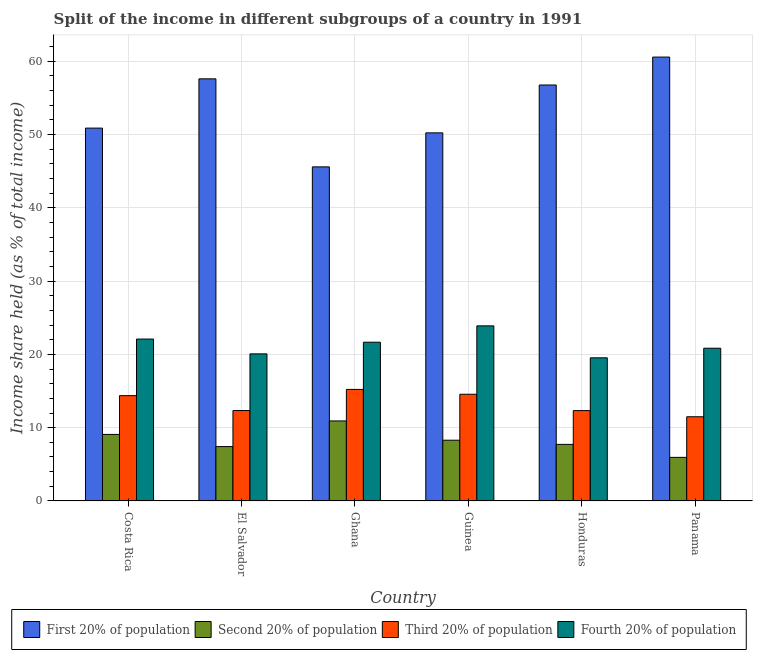How many different coloured bars are there?
Your response must be concise. 4. How many groups of bars are there?
Offer a terse response. 6. Are the number of bars per tick equal to the number of legend labels?
Make the answer very short. Yes. Are the number of bars on each tick of the X-axis equal?
Give a very brief answer. Yes. How many bars are there on the 5th tick from the right?
Provide a short and direct response. 4. What is the share of the income held by second 20% of the population in Ghana?
Your answer should be compact. 10.92. Across all countries, what is the maximum share of the income held by second 20% of the population?
Your answer should be compact. 10.92. Across all countries, what is the minimum share of the income held by third 20% of the population?
Offer a terse response. 11.49. In which country was the share of the income held by third 20% of the population maximum?
Make the answer very short. Ghana. In which country was the share of the income held by first 20% of the population minimum?
Provide a succinct answer. Ghana. What is the total share of the income held by third 20% of the population in the graph?
Your answer should be very brief. 80.31. What is the difference between the share of the income held by fourth 20% of the population in El Salvador and that in Guinea?
Give a very brief answer. -3.82. What is the difference between the share of the income held by second 20% of the population in Panama and the share of the income held by fourth 20% of the population in Guinea?
Your response must be concise. -17.94. What is the average share of the income held by fourth 20% of the population per country?
Ensure brevity in your answer.  21.35. What is the difference between the share of the income held by second 20% of the population and share of the income held by third 20% of the population in Ghana?
Provide a short and direct response. -4.3. In how many countries, is the share of the income held by first 20% of the population greater than 58 %?
Ensure brevity in your answer.  1. What is the ratio of the share of the income held by second 20% of the population in El Salvador to that in Panama?
Your response must be concise. 1.25. Is the difference between the share of the income held by third 20% of the population in Ghana and Panama greater than the difference between the share of the income held by second 20% of the population in Ghana and Panama?
Ensure brevity in your answer.  No. What is the difference between the highest and the second highest share of the income held by first 20% of the population?
Give a very brief answer. 2.97. What is the difference between the highest and the lowest share of the income held by third 20% of the population?
Make the answer very short. 3.73. What does the 4th bar from the left in Guinea represents?
Ensure brevity in your answer.  Fourth 20% of population. What does the 3rd bar from the right in Costa Rica represents?
Offer a very short reply. Second 20% of population. Is it the case that in every country, the sum of the share of the income held by first 20% of the population and share of the income held by second 20% of the population is greater than the share of the income held by third 20% of the population?
Provide a short and direct response. Yes. How many bars are there?
Give a very brief answer. 24. Are all the bars in the graph horizontal?
Make the answer very short. No. How many countries are there in the graph?
Your answer should be very brief. 6. What is the difference between two consecutive major ticks on the Y-axis?
Make the answer very short. 10. Are the values on the major ticks of Y-axis written in scientific E-notation?
Your response must be concise. No. Does the graph contain any zero values?
Your response must be concise. No. How are the legend labels stacked?
Your answer should be very brief. Horizontal. What is the title of the graph?
Provide a short and direct response. Split of the income in different subgroups of a country in 1991. Does "Financial sector" appear as one of the legend labels in the graph?
Provide a succinct answer. No. What is the label or title of the Y-axis?
Ensure brevity in your answer.  Income share held (as % of total income). What is the Income share held (as % of total income) in First 20% of population in Costa Rica?
Provide a succinct answer. 50.87. What is the Income share held (as % of total income) in Second 20% of population in Costa Rica?
Give a very brief answer. 9.08. What is the Income share held (as % of total income) in Third 20% of population in Costa Rica?
Make the answer very short. 14.37. What is the Income share held (as % of total income) in Fourth 20% of population in Costa Rica?
Make the answer very short. 22.09. What is the Income share held (as % of total income) in First 20% of population in El Salvador?
Keep it short and to the point. 57.59. What is the Income share held (as % of total income) in Second 20% of population in El Salvador?
Provide a short and direct response. 7.42. What is the Income share held (as % of total income) in Third 20% of population in El Salvador?
Keep it short and to the point. 12.34. What is the Income share held (as % of total income) in Fourth 20% of population in El Salvador?
Provide a short and direct response. 20.07. What is the Income share held (as % of total income) in First 20% of population in Ghana?
Ensure brevity in your answer.  45.58. What is the Income share held (as % of total income) of Second 20% of population in Ghana?
Offer a terse response. 10.92. What is the Income share held (as % of total income) of Third 20% of population in Ghana?
Provide a succinct answer. 15.22. What is the Income share held (as % of total income) in Fourth 20% of population in Ghana?
Make the answer very short. 21.66. What is the Income share held (as % of total income) of First 20% of population in Guinea?
Your response must be concise. 50.22. What is the Income share held (as % of total income) of Second 20% of population in Guinea?
Provide a succinct answer. 8.29. What is the Income share held (as % of total income) of Third 20% of population in Guinea?
Make the answer very short. 14.56. What is the Income share held (as % of total income) of Fourth 20% of population in Guinea?
Keep it short and to the point. 23.89. What is the Income share held (as % of total income) in First 20% of population in Honduras?
Ensure brevity in your answer.  56.75. What is the Income share held (as % of total income) in Second 20% of population in Honduras?
Your answer should be compact. 7.72. What is the Income share held (as % of total income) of Third 20% of population in Honduras?
Make the answer very short. 12.33. What is the Income share held (as % of total income) in Fourth 20% of population in Honduras?
Provide a short and direct response. 19.53. What is the Income share held (as % of total income) in First 20% of population in Panama?
Give a very brief answer. 60.56. What is the Income share held (as % of total income) of Second 20% of population in Panama?
Your answer should be compact. 5.95. What is the Income share held (as % of total income) of Third 20% of population in Panama?
Provide a short and direct response. 11.49. What is the Income share held (as % of total income) in Fourth 20% of population in Panama?
Provide a succinct answer. 20.84. Across all countries, what is the maximum Income share held (as % of total income) in First 20% of population?
Your answer should be compact. 60.56. Across all countries, what is the maximum Income share held (as % of total income) in Second 20% of population?
Keep it short and to the point. 10.92. Across all countries, what is the maximum Income share held (as % of total income) of Third 20% of population?
Your answer should be compact. 15.22. Across all countries, what is the maximum Income share held (as % of total income) of Fourth 20% of population?
Your answer should be compact. 23.89. Across all countries, what is the minimum Income share held (as % of total income) in First 20% of population?
Make the answer very short. 45.58. Across all countries, what is the minimum Income share held (as % of total income) of Second 20% of population?
Offer a very short reply. 5.95. Across all countries, what is the minimum Income share held (as % of total income) in Third 20% of population?
Your answer should be compact. 11.49. Across all countries, what is the minimum Income share held (as % of total income) in Fourth 20% of population?
Your response must be concise. 19.53. What is the total Income share held (as % of total income) of First 20% of population in the graph?
Your answer should be compact. 321.57. What is the total Income share held (as % of total income) of Second 20% of population in the graph?
Make the answer very short. 49.38. What is the total Income share held (as % of total income) of Third 20% of population in the graph?
Your answer should be compact. 80.31. What is the total Income share held (as % of total income) of Fourth 20% of population in the graph?
Offer a very short reply. 128.08. What is the difference between the Income share held (as % of total income) of First 20% of population in Costa Rica and that in El Salvador?
Give a very brief answer. -6.72. What is the difference between the Income share held (as % of total income) of Second 20% of population in Costa Rica and that in El Salvador?
Your answer should be very brief. 1.66. What is the difference between the Income share held (as % of total income) of Third 20% of population in Costa Rica and that in El Salvador?
Offer a very short reply. 2.03. What is the difference between the Income share held (as % of total income) in Fourth 20% of population in Costa Rica and that in El Salvador?
Your answer should be very brief. 2.02. What is the difference between the Income share held (as % of total income) of First 20% of population in Costa Rica and that in Ghana?
Provide a succinct answer. 5.29. What is the difference between the Income share held (as % of total income) in Second 20% of population in Costa Rica and that in Ghana?
Provide a succinct answer. -1.84. What is the difference between the Income share held (as % of total income) in Third 20% of population in Costa Rica and that in Ghana?
Give a very brief answer. -0.85. What is the difference between the Income share held (as % of total income) in Fourth 20% of population in Costa Rica and that in Ghana?
Offer a terse response. 0.43. What is the difference between the Income share held (as % of total income) in First 20% of population in Costa Rica and that in Guinea?
Offer a terse response. 0.65. What is the difference between the Income share held (as % of total income) of Second 20% of population in Costa Rica and that in Guinea?
Provide a short and direct response. 0.79. What is the difference between the Income share held (as % of total income) of Third 20% of population in Costa Rica and that in Guinea?
Your answer should be compact. -0.19. What is the difference between the Income share held (as % of total income) of First 20% of population in Costa Rica and that in Honduras?
Provide a succinct answer. -5.88. What is the difference between the Income share held (as % of total income) of Second 20% of population in Costa Rica and that in Honduras?
Give a very brief answer. 1.36. What is the difference between the Income share held (as % of total income) in Third 20% of population in Costa Rica and that in Honduras?
Make the answer very short. 2.04. What is the difference between the Income share held (as % of total income) of Fourth 20% of population in Costa Rica and that in Honduras?
Your answer should be compact. 2.56. What is the difference between the Income share held (as % of total income) of First 20% of population in Costa Rica and that in Panama?
Your answer should be very brief. -9.69. What is the difference between the Income share held (as % of total income) of Second 20% of population in Costa Rica and that in Panama?
Provide a succinct answer. 3.13. What is the difference between the Income share held (as % of total income) in Third 20% of population in Costa Rica and that in Panama?
Provide a short and direct response. 2.88. What is the difference between the Income share held (as % of total income) of First 20% of population in El Salvador and that in Ghana?
Offer a very short reply. 12.01. What is the difference between the Income share held (as % of total income) in Second 20% of population in El Salvador and that in Ghana?
Keep it short and to the point. -3.5. What is the difference between the Income share held (as % of total income) in Third 20% of population in El Salvador and that in Ghana?
Provide a short and direct response. -2.88. What is the difference between the Income share held (as % of total income) in Fourth 20% of population in El Salvador and that in Ghana?
Your response must be concise. -1.59. What is the difference between the Income share held (as % of total income) of First 20% of population in El Salvador and that in Guinea?
Offer a very short reply. 7.37. What is the difference between the Income share held (as % of total income) in Second 20% of population in El Salvador and that in Guinea?
Your response must be concise. -0.87. What is the difference between the Income share held (as % of total income) in Third 20% of population in El Salvador and that in Guinea?
Offer a very short reply. -2.22. What is the difference between the Income share held (as % of total income) in Fourth 20% of population in El Salvador and that in Guinea?
Your answer should be compact. -3.82. What is the difference between the Income share held (as % of total income) in First 20% of population in El Salvador and that in Honduras?
Your answer should be very brief. 0.84. What is the difference between the Income share held (as % of total income) in Second 20% of population in El Salvador and that in Honduras?
Ensure brevity in your answer.  -0.3. What is the difference between the Income share held (as % of total income) of Third 20% of population in El Salvador and that in Honduras?
Give a very brief answer. 0.01. What is the difference between the Income share held (as % of total income) in Fourth 20% of population in El Salvador and that in Honduras?
Offer a terse response. 0.54. What is the difference between the Income share held (as % of total income) in First 20% of population in El Salvador and that in Panama?
Keep it short and to the point. -2.97. What is the difference between the Income share held (as % of total income) of Second 20% of population in El Salvador and that in Panama?
Keep it short and to the point. 1.47. What is the difference between the Income share held (as % of total income) in Third 20% of population in El Salvador and that in Panama?
Ensure brevity in your answer.  0.85. What is the difference between the Income share held (as % of total income) of Fourth 20% of population in El Salvador and that in Panama?
Provide a short and direct response. -0.77. What is the difference between the Income share held (as % of total income) in First 20% of population in Ghana and that in Guinea?
Offer a terse response. -4.64. What is the difference between the Income share held (as % of total income) in Second 20% of population in Ghana and that in Guinea?
Your answer should be very brief. 2.63. What is the difference between the Income share held (as % of total income) of Third 20% of population in Ghana and that in Guinea?
Keep it short and to the point. 0.66. What is the difference between the Income share held (as % of total income) of Fourth 20% of population in Ghana and that in Guinea?
Offer a very short reply. -2.23. What is the difference between the Income share held (as % of total income) of First 20% of population in Ghana and that in Honduras?
Give a very brief answer. -11.17. What is the difference between the Income share held (as % of total income) of Second 20% of population in Ghana and that in Honduras?
Offer a very short reply. 3.2. What is the difference between the Income share held (as % of total income) in Third 20% of population in Ghana and that in Honduras?
Ensure brevity in your answer.  2.89. What is the difference between the Income share held (as % of total income) of Fourth 20% of population in Ghana and that in Honduras?
Make the answer very short. 2.13. What is the difference between the Income share held (as % of total income) in First 20% of population in Ghana and that in Panama?
Provide a short and direct response. -14.98. What is the difference between the Income share held (as % of total income) of Second 20% of population in Ghana and that in Panama?
Your response must be concise. 4.97. What is the difference between the Income share held (as % of total income) in Third 20% of population in Ghana and that in Panama?
Keep it short and to the point. 3.73. What is the difference between the Income share held (as % of total income) of Fourth 20% of population in Ghana and that in Panama?
Offer a terse response. 0.82. What is the difference between the Income share held (as % of total income) of First 20% of population in Guinea and that in Honduras?
Keep it short and to the point. -6.53. What is the difference between the Income share held (as % of total income) in Second 20% of population in Guinea and that in Honduras?
Offer a terse response. 0.57. What is the difference between the Income share held (as % of total income) of Third 20% of population in Guinea and that in Honduras?
Your response must be concise. 2.23. What is the difference between the Income share held (as % of total income) of Fourth 20% of population in Guinea and that in Honduras?
Make the answer very short. 4.36. What is the difference between the Income share held (as % of total income) in First 20% of population in Guinea and that in Panama?
Your answer should be compact. -10.34. What is the difference between the Income share held (as % of total income) of Second 20% of population in Guinea and that in Panama?
Ensure brevity in your answer.  2.34. What is the difference between the Income share held (as % of total income) of Third 20% of population in Guinea and that in Panama?
Offer a very short reply. 3.07. What is the difference between the Income share held (as % of total income) in Fourth 20% of population in Guinea and that in Panama?
Make the answer very short. 3.05. What is the difference between the Income share held (as % of total income) in First 20% of population in Honduras and that in Panama?
Make the answer very short. -3.81. What is the difference between the Income share held (as % of total income) in Second 20% of population in Honduras and that in Panama?
Keep it short and to the point. 1.77. What is the difference between the Income share held (as % of total income) of Third 20% of population in Honduras and that in Panama?
Your answer should be compact. 0.84. What is the difference between the Income share held (as % of total income) in Fourth 20% of population in Honduras and that in Panama?
Provide a succinct answer. -1.31. What is the difference between the Income share held (as % of total income) in First 20% of population in Costa Rica and the Income share held (as % of total income) in Second 20% of population in El Salvador?
Keep it short and to the point. 43.45. What is the difference between the Income share held (as % of total income) in First 20% of population in Costa Rica and the Income share held (as % of total income) in Third 20% of population in El Salvador?
Your response must be concise. 38.53. What is the difference between the Income share held (as % of total income) in First 20% of population in Costa Rica and the Income share held (as % of total income) in Fourth 20% of population in El Salvador?
Offer a terse response. 30.8. What is the difference between the Income share held (as % of total income) of Second 20% of population in Costa Rica and the Income share held (as % of total income) of Third 20% of population in El Salvador?
Provide a succinct answer. -3.26. What is the difference between the Income share held (as % of total income) of Second 20% of population in Costa Rica and the Income share held (as % of total income) of Fourth 20% of population in El Salvador?
Give a very brief answer. -10.99. What is the difference between the Income share held (as % of total income) of Third 20% of population in Costa Rica and the Income share held (as % of total income) of Fourth 20% of population in El Salvador?
Your answer should be compact. -5.7. What is the difference between the Income share held (as % of total income) of First 20% of population in Costa Rica and the Income share held (as % of total income) of Second 20% of population in Ghana?
Provide a succinct answer. 39.95. What is the difference between the Income share held (as % of total income) in First 20% of population in Costa Rica and the Income share held (as % of total income) in Third 20% of population in Ghana?
Your response must be concise. 35.65. What is the difference between the Income share held (as % of total income) of First 20% of population in Costa Rica and the Income share held (as % of total income) of Fourth 20% of population in Ghana?
Your answer should be very brief. 29.21. What is the difference between the Income share held (as % of total income) of Second 20% of population in Costa Rica and the Income share held (as % of total income) of Third 20% of population in Ghana?
Offer a terse response. -6.14. What is the difference between the Income share held (as % of total income) of Second 20% of population in Costa Rica and the Income share held (as % of total income) of Fourth 20% of population in Ghana?
Offer a terse response. -12.58. What is the difference between the Income share held (as % of total income) in Third 20% of population in Costa Rica and the Income share held (as % of total income) in Fourth 20% of population in Ghana?
Ensure brevity in your answer.  -7.29. What is the difference between the Income share held (as % of total income) in First 20% of population in Costa Rica and the Income share held (as % of total income) in Second 20% of population in Guinea?
Your response must be concise. 42.58. What is the difference between the Income share held (as % of total income) of First 20% of population in Costa Rica and the Income share held (as % of total income) of Third 20% of population in Guinea?
Your answer should be compact. 36.31. What is the difference between the Income share held (as % of total income) of First 20% of population in Costa Rica and the Income share held (as % of total income) of Fourth 20% of population in Guinea?
Your answer should be very brief. 26.98. What is the difference between the Income share held (as % of total income) in Second 20% of population in Costa Rica and the Income share held (as % of total income) in Third 20% of population in Guinea?
Offer a terse response. -5.48. What is the difference between the Income share held (as % of total income) of Second 20% of population in Costa Rica and the Income share held (as % of total income) of Fourth 20% of population in Guinea?
Give a very brief answer. -14.81. What is the difference between the Income share held (as % of total income) of Third 20% of population in Costa Rica and the Income share held (as % of total income) of Fourth 20% of population in Guinea?
Your response must be concise. -9.52. What is the difference between the Income share held (as % of total income) in First 20% of population in Costa Rica and the Income share held (as % of total income) in Second 20% of population in Honduras?
Make the answer very short. 43.15. What is the difference between the Income share held (as % of total income) of First 20% of population in Costa Rica and the Income share held (as % of total income) of Third 20% of population in Honduras?
Your answer should be very brief. 38.54. What is the difference between the Income share held (as % of total income) in First 20% of population in Costa Rica and the Income share held (as % of total income) in Fourth 20% of population in Honduras?
Keep it short and to the point. 31.34. What is the difference between the Income share held (as % of total income) of Second 20% of population in Costa Rica and the Income share held (as % of total income) of Third 20% of population in Honduras?
Provide a short and direct response. -3.25. What is the difference between the Income share held (as % of total income) in Second 20% of population in Costa Rica and the Income share held (as % of total income) in Fourth 20% of population in Honduras?
Provide a succinct answer. -10.45. What is the difference between the Income share held (as % of total income) in Third 20% of population in Costa Rica and the Income share held (as % of total income) in Fourth 20% of population in Honduras?
Make the answer very short. -5.16. What is the difference between the Income share held (as % of total income) in First 20% of population in Costa Rica and the Income share held (as % of total income) in Second 20% of population in Panama?
Your answer should be very brief. 44.92. What is the difference between the Income share held (as % of total income) in First 20% of population in Costa Rica and the Income share held (as % of total income) in Third 20% of population in Panama?
Offer a terse response. 39.38. What is the difference between the Income share held (as % of total income) of First 20% of population in Costa Rica and the Income share held (as % of total income) of Fourth 20% of population in Panama?
Your answer should be compact. 30.03. What is the difference between the Income share held (as % of total income) of Second 20% of population in Costa Rica and the Income share held (as % of total income) of Third 20% of population in Panama?
Offer a very short reply. -2.41. What is the difference between the Income share held (as % of total income) of Second 20% of population in Costa Rica and the Income share held (as % of total income) of Fourth 20% of population in Panama?
Ensure brevity in your answer.  -11.76. What is the difference between the Income share held (as % of total income) of Third 20% of population in Costa Rica and the Income share held (as % of total income) of Fourth 20% of population in Panama?
Give a very brief answer. -6.47. What is the difference between the Income share held (as % of total income) of First 20% of population in El Salvador and the Income share held (as % of total income) of Second 20% of population in Ghana?
Keep it short and to the point. 46.67. What is the difference between the Income share held (as % of total income) in First 20% of population in El Salvador and the Income share held (as % of total income) in Third 20% of population in Ghana?
Make the answer very short. 42.37. What is the difference between the Income share held (as % of total income) of First 20% of population in El Salvador and the Income share held (as % of total income) of Fourth 20% of population in Ghana?
Offer a very short reply. 35.93. What is the difference between the Income share held (as % of total income) of Second 20% of population in El Salvador and the Income share held (as % of total income) of Fourth 20% of population in Ghana?
Offer a terse response. -14.24. What is the difference between the Income share held (as % of total income) of Third 20% of population in El Salvador and the Income share held (as % of total income) of Fourth 20% of population in Ghana?
Give a very brief answer. -9.32. What is the difference between the Income share held (as % of total income) in First 20% of population in El Salvador and the Income share held (as % of total income) in Second 20% of population in Guinea?
Ensure brevity in your answer.  49.3. What is the difference between the Income share held (as % of total income) in First 20% of population in El Salvador and the Income share held (as % of total income) in Third 20% of population in Guinea?
Provide a succinct answer. 43.03. What is the difference between the Income share held (as % of total income) of First 20% of population in El Salvador and the Income share held (as % of total income) of Fourth 20% of population in Guinea?
Keep it short and to the point. 33.7. What is the difference between the Income share held (as % of total income) of Second 20% of population in El Salvador and the Income share held (as % of total income) of Third 20% of population in Guinea?
Offer a very short reply. -7.14. What is the difference between the Income share held (as % of total income) in Second 20% of population in El Salvador and the Income share held (as % of total income) in Fourth 20% of population in Guinea?
Provide a succinct answer. -16.47. What is the difference between the Income share held (as % of total income) in Third 20% of population in El Salvador and the Income share held (as % of total income) in Fourth 20% of population in Guinea?
Provide a succinct answer. -11.55. What is the difference between the Income share held (as % of total income) in First 20% of population in El Salvador and the Income share held (as % of total income) in Second 20% of population in Honduras?
Your answer should be compact. 49.87. What is the difference between the Income share held (as % of total income) in First 20% of population in El Salvador and the Income share held (as % of total income) in Third 20% of population in Honduras?
Your answer should be very brief. 45.26. What is the difference between the Income share held (as % of total income) of First 20% of population in El Salvador and the Income share held (as % of total income) of Fourth 20% of population in Honduras?
Provide a succinct answer. 38.06. What is the difference between the Income share held (as % of total income) of Second 20% of population in El Salvador and the Income share held (as % of total income) of Third 20% of population in Honduras?
Offer a very short reply. -4.91. What is the difference between the Income share held (as % of total income) in Second 20% of population in El Salvador and the Income share held (as % of total income) in Fourth 20% of population in Honduras?
Offer a very short reply. -12.11. What is the difference between the Income share held (as % of total income) of Third 20% of population in El Salvador and the Income share held (as % of total income) of Fourth 20% of population in Honduras?
Ensure brevity in your answer.  -7.19. What is the difference between the Income share held (as % of total income) of First 20% of population in El Salvador and the Income share held (as % of total income) of Second 20% of population in Panama?
Your answer should be very brief. 51.64. What is the difference between the Income share held (as % of total income) of First 20% of population in El Salvador and the Income share held (as % of total income) of Third 20% of population in Panama?
Offer a very short reply. 46.1. What is the difference between the Income share held (as % of total income) of First 20% of population in El Salvador and the Income share held (as % of total income) of Fourth 20% of population in Panama?
Give a very brief answer. 36.75. What is the difference between the Income share held (as % of total income) in Second 20% of population in El Salvador and the Income share held (as % of total income) in Third 20% of population in Panama?
Your answer should be very brief. -4.07. What is the difference between the Income share held (as % of total income) in Second 20% of population in El Salvador and the Income share held (as % of total income) in Fourth 20% of population in Panama?
Your response must be concise. -13.42. What is the difference between the Income share held (as % of total income) in First 20% of population in Ghana and the Income share held (as % of total income) in Second 20% of population in Guinea?
Your answer should be compact. 37.29. What is the difference between the Income share held (as % of total income) in First 20% of population in Ghana and the Income share held (as % of total income) in Third 20% of population in Guinea?
Provide a succinct answer. 31.02. What is the difference between the Income share held (as % of total income) of First 20% of population in Ghana and the Income share held (as % of total income) of Fourth 20% of population in Guinea?
Ensure brevity in your answer.  21.69. What is the difference between the Income share held (as % of total income) of Second 20% of population in Ghana and the Income share held (as % of total income) of Third 20% of population in Guinea?
Offer a terse response. -3.64. What is the difference between the Income share held (as % of total income) in Second 20% of population in Ghana and the Income share held (as % of total income) in Fourth 20% of population in Guinea?
Provide a succinct answer. -12.97. What is the difference between the Income share held (as % of total income) of Third 20% of population in Ghana and the Income share held (as % of total income) of Fourth 20% of population in Guinea?
Offer a very short reply. -8.67. What is the difference between the Income share held (as % of total income) of First 20% of population in Ghana and the Income share held (as % of total income) of Second 20% of population in Honduras?
Offer a terse response. 37.86. What is the difference between the Income share held (as % of total income) in First 20% of population in Ghana and the Income share held (as % of total income) in Third 20% of population in Honduras?
Make the answer very short. 33.25. What is the difference between the Income share held (as % of total income) of First 20% of population in Ghana and the Income share held (as % of total income) of Fourth 20% of population in Honduras?
Offer a terse response. 26.05. What is the difference between the Income share held (as % of total income) in Second 20% of population in Ghana and the Income share held (as % of total income) in Third 20% of population in Honduras?
Offer a terse response. -1.41. What is the difference between the Income share held (as % of total income) in Second 20% of population in Ghana and the Income share held (as % of total income) in Fourth 20% of population in Honduras?
Provide a succinct answer. -8.61. What is the difference between the Income share held (as % of total income) of Third 20% of population in Ghana and the Income share held (as % of total income) of Fourth 20% of population in Honduras?
Provide a succinct answer. -4.31. What is the difference between the Income share held (as % of total income) in First 20% of population in Ghana and the Income share held (as % of total income) in Second 20% of population in Panama?
Give a very brief answer. 39.63. What is the difference between the Income share held (as % of total income) in First 20% of population in Ghana and the Income share held (as % of total income) in Third 20% of population in Panama?
Make the answer very short. 34.09. What is the difference between the Income share held (as % of total income) of First 20% of population in Ghana and the Income share held (as % of total income) of Fourth 20% of population in Panama?
Provide a short and direct response. 24.74. What is the difference between the Income share held (as % of total income) in Second 20% of population in Ghana and the Income share held (as % of total income) in Third 20% of population in Panama?
Offer a terse response. -0.57. What is the difference between the Income share held (as % of total income) of Second 20% of population in Ghana and the Income share held (as % of total income) of Fourth 20% of population in Panama?
Offer a very short reply. -9.92. What is the difference between the Income share held (as % of total income) of Third 20% of population in Ghana and the Income share held (as % of total income) of Fourth 20% of population in Panama?
Make the answer very short. -5.62. What is the difference between the Income share held (as % of total income) in First 20% of population in Guinea and the Income share held (as % of total income) in Second 20% of population in Honduras?
Provide a succinct answer. 42.5. What is the difference between the Income share held (as % of total income) of First 20% of population in Guinea and the Income share held (as % of total income) of Third 20% of population in Honduras?
Your answer should be very brief. 37.89. What is the difference between the Income share held (as % of total income) of First 20% of population in Guinea and the Income share held (as % of total income) of Fourth 20% of population in Honduras?
Keep it short and to the point. 30.69. What is the difference between the Income share held (as % of total income) in Second 20% of population in Guinea and the Income share held (as % of total income) in Third 20% of population in Honduras?
Your answer should be compact. -4.04. What is the difference between the Income share held (as % of total income) of Second 20% of population in Guinea and the Income share held (as % of total income) of Fourth 20% of population in Honduras?
Provide a succinct answer. -11.24. What is the difference between the Income share held (as % of total income) in Third 20% of population in Guinea and the Income share held (as % of total income) in Fourth 20% of population in Honduras?
Your answer should be compact. -4.97. What is the difference between the Income share held (as % of total income) of First 20% of population in Guinea and the Income share held (as % of total income) of Second 20% of population in Panama?
Offer a terse response. 44.27. What is the difference between the Income share held (as % of total income) of First 20% of population in Guinea and the Income share held (as % of total income) of Third 20% of population in Panama?
Provide a short and direct response. 38.73. What is the difference between the Income share held (as % of total income) of First 20% of population in Guinea and the Income share held (as % of total income) of Fourth 20% of population in Panama?
Offer a terse response. 29.38. What is the difference between the Income share held (as % of total income) in Second 20% of population in Guinea and the Income share held (as % of total income) in Fourth 20% of population in Panama?
Keep it short and to the point. -12.55. What is the difference between the Income share held (as % of total income) of Third 20% of population in Guinea and the Income share held (as % of total income) of Fourth 20% of population in Panama?
Your answer should be compact. -6.28. What is the difference between the Income share held (as % of total income) in First 20% of population in Honduras and the Income share held (as % of total income) in Second 20% of population in Panama?
Offer a very short reply. 50.8. What is the difference between the Income share held (as % of total income) of First 20% of population in Honduras and the Income share held (as % of total income) of Third 20% of population in Panama?
Offer a terse response. 45.26. What is the difference between the Income share held (as % of total income) of First 20% of population in Honduras and the Income share held (as % of total income) of Fourth 20% of population in Panama?
Provide a succinct answer. 35.91. What is the difference between the Income share held (as % of total income) of Second 20% of population in Honduras and the Income share held (as % of total income) of Third 20% of population in Panama?
Keep it short and to the point. -3.77. What is the difference between the Income share held (as % of total income) of Second 20% of population in Honduras and the Income share held (as % of total income) of Fourth 20% of population in Panama?
Your response must be concise. -13.12. What is the difference between the Income share held (as % of total income) in Third 20% of population in Honduras and the Income share held (as % of total income) in Fourth 20% of population in Panama?
Your answer should be very brief. -8.51. What is the average Income share held (as % of total income) in First 20% of population per country?
Provide a short and direct response. 53.59. What is the average Income share held (as % of total income) in Second 20% of population per country?
Offer a terse response. 8.23. What is the average Income share held (as % of total income) of Third 20% of population per country?
Keep it short and to the point. 13.38. What is the average Income share held (as % of total income) in Fourth 20% of population per country?
Provide a short and direct response. 21.35. What is the difference between the Income share held (as % of total income) in First 20% of population and Income share held (as % of total income) in Second 20% of population in Costa Rica?
Make the answer very short. 41.79. What is the difference between the Income share held (as % of total income) in First 20% of population and Income share held (as % of total income) in Third 20% of population in Costa Rica?
Keep it short and to the point. 36.5. What is the difference between the Income share held (as % of total income) of First 20% of population and Income share held (as % of total income) of Fourth 20% of population in Costa Rica?
Ensure brevity in your answer.  28.78. What is the difference between the Income share held (as % of total income) of Second 20% of population and Income share held (as % of total income) of Third 20% of population in Costa Rica?
Ensure brevity in your answer.  -5.29. What is the difference between the Income share held (as % of total income) of Second 20% of population and Income share held (as % of total income) of Fourth 20% of population in Costa Rica?
Provide a succinct answer. -13.01. What is the difference between the Income share held (as % of total income) in Third 20% of population and Income share held (as % of total income) in Fourth 20% of population in Costa Rica?
Offer a terse response. -7.72. What is the difference between the Income share held (as % of total income) in First 20% of population and Income share held (as % of total income) in Second 20% of population in El Salvador?
Your answer should be compact. 50.17. What is the difference between the Income share held (as % of total income) of First 20% of population and Income share held (as % of total income) of Third 20% of population in El Salvador?
Make the answer very short. 45.25. What is the difference between the Income share held (as % of total income) in First 20% of population and Income share held (as % of total income) in Fourth 20% of population in El Salvador?
Offer a very short reply. 37.52. What is the difference between the Income share held (as % of total income) of Second 20% of population and Income share held (as % of total income) of Third 20% of population in El Salvador?
Make the answer very short. -4.92. What is the difference between the Income share held (as % of total income) of Second 20% of population and Income share held (as % of total income) of Fourth 20% of population in El Salvador?
Your answer should be compact. -12.65. What is the difference between the Income share held (as % of total income) of Third 20% of population and Income share held (as % of total income) of Fourth 20% of population in El Salvador?
Make the answer very short. -7.73. What is the difference between the Income share held (as % of total income) in First 20% of population and Income share held (as % of total income) in Second 20% of population in Ghana?
Provide a short and direct response. 34.66. What is the difference between the Income share held (as % of total income) of First 20% of population and Income share held (as % of total income) of Third 20% of population in Ghana?
Keep it short and to the point. 30.36. What is the difference between the Income share held (as % of total income) in First 20% of population and Income share held (as % of total income) in Fourth 20% of population in Ghana?
Ensure brevity in your answer.  23.92. What is the difference between the Income share held (as % of total income) of Second 20% of population and Income share held (as % of total income) of Third 20% of population in Ghana?
Provide a short and direct response. -4.3. What is the difference between the Income share held (as % of total income) of Second 20% of population and Income share held (as % of total income) of Fourth 20% of population in Ghana?
Provide a short and direct response. -10.74. What is the difference between the Income share held (as % of total income) of Third 20% of population and Income share held (as % of total income) of Fourth 20% of population in Ghana?
Make the answer very short. -6.44. What is the difference between the Income share held (as % of total income) in First 20% of population and Income share held (as % of total income) in Second 20% of population in Guinea?
Provide a short and direct response. 41.93. What is the difference between the Income share held (as % of total income) of First 20% of population and Income share held (as % of total income) of Third 20% of population in Guinea?
Provide a short and direct response. 35.66. What is the difference between the Income share held (as % of total income) of First 20% of population and Income share held (as % of total income) of Fourth 20% of population in Guinea?
Your answer should be very brief. 26.33. What is the difference between the Income share held (as % of total income) of Second 20% of population and Income share held (as % of total income) of Third 20% of population in Guinea?
Make the answer very short. -6.27. What is the difference between the Income share held (as % of total income) of Second 20% of population and Income share held (as % of total income) of Fourth 20% of population in Guinea?
Offer a terse response. -15.6. What is the difference between the Income share held (as % of total income) in Third 20% of population and Income share held (as % of total income) in Fourth 20% of population in Guinea?
Your response must be concise. -9.33. What is the difference between the Income share held (as % of total income) of First 20% of population and Income share held (as % of total income) of Second 20% of population in Honduras?
Your answer should be compact. 49.03. What is the difference between the Income share held (as % of total income) of First 20% of population and Income share held (as % of total income) of Third 20% of population in Honduras?
Provide a succinct answer. 44.42. What is the difference between the Income share held (as % of total income) of First 20% of population and Income share held (as % of total income) of Fourth 20% of population in Honduras?
Your response must be concise. 37.22. What is the difference between the Income share held (as % of total income) in Second 20% of population and Income share held (as % of total income) in Third 20% of population in Honduras?
Provide a short and direct response. -4.61. What is the difference between the Income share held (as % of total income) of Second 20% of population and Income share held (as % of total income) of Fourth 20% of population in Honduras?
Provide a succinct answer. -11.81. What is the difference between the Income share held (as % of total income) of First 20% of population and Income share held (as % of total income) of Second 20% of population in Panama?
Make the answer very short. 54.61. What is the difference between the Income share held (as % of total income) in First 20% of population and Income share held (as % of total income) in Third 20% of population in Panama?
Make the answer very short. 49.07. What is the difference between the Income share held (as % of total income) in First 20% of population and Income share held (as % of total income) in Fourth 20% of population in Panama?
Your response must be concise. 39.72. What is the difference between the Income share held (as % of total income) in Second 20% of population and Income share held (as % of total income) in Third 20% of population in Panama?
Give a very brief answer. -5.54. What is the difference between the Income share held (as % of total income) in Second 20% of population and Income share held (as % of total income) in Fourth 20% of population in Panama?
Your response must be concise. -14.89. What is the difference between the Income share held (as % of total income) in Third 20% of population and Income share held (as % of total income) in Fourth 20% of population in Panama?
Offer a terse response. -9.35. What is the ratio of the Income share held (as % of total income) in First 20% of population in Costa Rica to that in El Salvador?
Your response must be concise. 0.88. What is the ratio of the Income share held (as % of total income) of Second 20% of population in Costa Rica to that in El Salvador?
Provide a succinct answer. 1.22. What is the ratio of the Income share held (as % of total income) of Third 20% of population in Costa Rica to that in El Salvador?
Keep it short and to the point. 1.16. What is the ratio of the Income share held (as % of total income) in Fourth 20% of population in Costa Rica to that in El Salvador?
Give a very brief answer. 1.1. What is the ratio of the Income share held (as % of total income) in First 20% of population in Costa Rica to that in Ghana?
Make the answer very short. 1.12. What is the ratio of the Income share held (as % of total income) in Second 20% of population in Costa Rica to that in Ghana?
Give a very brief answer. 0.83. What is the ratio of the Income share held (as % of total income) in Third 20% of population in Costa Rica to that in Ghana?
Keep it short and to the point. 0.94. What is the ratio of the Income share held (as % of total income) of Fourth 20% of population in Costa Rica to that in Ghana?
Make the answer very short. 1.02. What is the ratio of the Income share held (as % of total income) in First 20% of population in Costa Rica to that in Guinea?
Offer a very short reply. 1.01. What is the ratio of the Income share held (as % of total income) of Second 20% of population in Costa Rica to that in Guinea?
Keep it short and to the point. 1.1. What is the ratio of the Income share held (as % of total income) of Fourth 20% of population in Costa Rica to that in Guinea?
Ensure brevity in your answer.  0.92. What is the ratio of the Income share held (as % of total income) in First 20% of population in Costa Rica to that in Honduras?
Your answer should be compact. 0.9. What is the ratio of the Income share held (as % of total income) in Second 20% of population in Costa Rica to that in Honduras?
Provide a short and direct response. 1.18. What is the ratio of the Income share held (as % of total income) of Third 20% of population in Costa Rica to that in Honduras?
Provide a short and direct response. 1.17. What is the ratio of the Income share held (as % of total income) of Fourth 20% of population in Costa Rica to that in Honduras?
Your answer should be very brief. 1.13. What is the ratio of the Income share held (as % of total income) of First 20% of population in Costa Rica to that in Panama?
Offer a very short reply. 0.84. What is the ratio of the Income share held (as % of total income) in Second 20% of population in Costa Rica to that in Panama?
Ensure brevity in your answer.  1.53. What is the ratio of the Income share held (as % of total income) in Third 20% of population in Costa Rica to that in Panama?
Your answer should be compact. 1.25. What is the ratio of the Income share held (as % of total income) in Fourth 20% of population in Costa Rica to that in Panama?
Ensure brevity in your answer.  1.06. What is the ratio of the Income share held (as % of total income) of First 20% of population in El Salvador to that in Ghana?
Provide a short and direct response. 1.26. What is the ratio of the Income share held (as % of total income) of Second 20% of population in El Salvador to that in Ghana?
Provide a succinct answer. 0.68. What is the ratio of the Income share held (as % of total income) of Third 20% of population in El Salvador to that in Ghana?
Provide a succinct answer. 0.81. What is the ratio of the Income share held (as % of total income) of Fourth 20% of population in El Salvador to that in Ghana?
Provide a succinct answer. 0.93. What is the ratio of the Income share held (as % of total income) in First 20% of population in El Salvador to that in Guinea?
Give a very brief answer. 1.15. What is the ratio of the Income share held (as % of total income) in Second 20% of population in El Salvador to that in Guinea?
Offer a terse response. 0.9. What is the ratio of the Income share held (as % of total income) of Third 20% of population in El Salvador to that in Guinea?
Provide a succinct answer. 0.85. What is the ratio of the Income share held (as % of total income) of Fourth 20% of population in El Salvador to that in Guinea?
Ensure brevity in your answer.  0.84. What is the ratio of the Income share held (as % of total income) in First 20% of population in El Salvador to that in Honduras?
Make the answer very short. 1.01. What is the ratio of the Income share held (as % of total income) of Second 20% of population in El Salvador to that in Honduras?
Give a very brief answer. 0.96. What is the ratio of the Income share held (as % of total income) in Third 20% of population in El Salvador to that in Honduras?
Your response must be concise. 1. What is the ratio of the Income share held (as % of total income) in Fourth 20% of population in El Salvador to that in Honduras?
Your response must be concise. 1.03. What is the ratio of the Income share held (as % of total income) of First 20% of population in El Salvador to that in Panama?
Your response must be concise. 0.95. What is the ratio of the Income share held (as % of total income) of Second 20% of population in El Salvador to that in Panama?
Make the answer very short. 1.25. What is the ratio of the Income share held (as % of total income) of Third 20% of population in El Salvador to that in Panama?
Offer a very short reply. 1.07. What is the ratio of the Income share held (as % of total income) in Fourth 20% of population in El Salvador to that in Panama?
Ensure brevity in your answer.  0.96. What is the ratio of the Income share held (as % of total income) of First 20% of population in Ghana to that in Guinea?
Offer a very short reply. 0.91. What is the ratio of the Income share held (as % of total income) in Second 20% of population in Ghana to that in Guinea?
Your response must be concise. 1.32. What is the ratio of the Income share held (as % of total income) in Third 20% of population in Ghana to that in Guinea?
Your response must be concise. 1.05. What is the ratio of the Income share held (as % of total income) of Fourth 20% of population in Ghana to that in Guinea?
Offer a very short reply. 0.91. What is the ratio of the Income share held (as % of total income) of First 20% of population in Ghana to that in Honduras?
Your answer should be compact. 0.8. What is the ratio of the Income share held (as % of total income) in Second 20% of population in Ghana to that in Honduras?
Your response must be concise. 1.41. What is the ratio of the Income share held (as % of total income) of Third 20% of population in Ghana to that in Honduras?
Give a very brief answer. 1.23. What is the ratio of the Income share held (as % of total income) of Fourth 20% of population in Ghana to that in Honduras?
Your answer should be compact. 1.11. What is the ratio of the Income share held (as % of total income) of First 20% of population in Ghana to that in Panama?
Your answer should be very brief. 0.75. What is the ratio of the Income share held (as % of total income) in Second 20% of population in Ghana to that in Panama?
Your response must be concise. 1.84. What is the ratio of the Income share held (as % of total income) of Third 20% of population in Ghana to that in Panama?
Give a very brief answer. 1.32. What is the ratio of the Income share held (as % of total income) of Fourth 20% of population in Ghana to that in Panama?
Provide a succinct answer. 1.04. What is the ratio of the Income share held (as % of total income) in First 20% of population in Guinea to that in Honduras?
Provide a succinct answer. 0.88. What is the ratio of the Income share held (as % of total income) of Second 20% of population in Guinea to that in Honduras?
Keep it short and to the point. 1.07. What is the ratio of the Income share held (as % of total income) of Third 20% of population in Guinea to that in Honduras?
Ensure brevity in your answer.  1.18. What is the ratio of the Income share held (as % of total income) in Fourth 20% of population in Guinea to that in Honduras?
Your answer should be compact. 1.22. What is the ratio of the Income share held (as % of total income) of First 20% of population in Guinea to that in Panama?
Your answer should be very brief. 0.83. What is the ratio of the Income share held (as % of total income) in Second 20% of population in Guinea to that in Panama?
Your answer should be very brief. 1.39. What is the ratio of the Income share held (as % of total income) of Third 20% of population in Guinea to that in Panama?
Offer a terse response. 1.27. What is the ratio of the Income share held (as % of total income) of Fourth 20% of population in Guinea to that in Panama?
Your answer should be compact. 1.15. What is the ratio of the Income share held (as % of total income) of First 20% of population in Honduras to that in Panama?
Make the answer very short. 0.94. What is the ratio of the Income share held (as % of total income) in Second 20% of population in Honduras to that in Panama?
Your answer should be very brief. 1.3. What is the ratio of the Income share held (as % of total income) in Third 20% of population in Honduras to that in Panama?
Offer a terse response. 1.07. What is the ratio of the Income share held (as % of total income) in Fourth 20% of population in Honduras to that in Panama?
Your response must be concise. 0.94. What is the difference between the highest and the second highest Income share held (as % of total income) of First 20% of population?
Offer a terse response. 2.97. What is the difference between the highest and the second highest Income share held (as % of total income) of Second 20% of population?
Keep it short and to the point. 1.84. What is the difference between the highest and the second highest Income share held (as % of total income) in Third 20% of population?
Provide a succinct answer. 0.66. What is the difference between the highest and the second highest Income share held (as % of total income) in Fourth 20% of population?
Give a very brief answer. 1.8. What is the difference between the highest and the lowest Income share held (as % of total income) in First 20% of population?
Make the answer very short. 14.98. What is the difference between the highest and the lowest Income share held (as % of total income) of Second 20% of population?
Provide a succinct answer. 4.97. What is the difference between the highest and the lowest Income share held (as % of total income) in Third 20% of population?
Ensure brevity in your answer.  3.73. What is the difference between the highest and the lowest Income share held (as % of total income) of Fourth 20% of population?
Give a very brief answer. 4.36. 